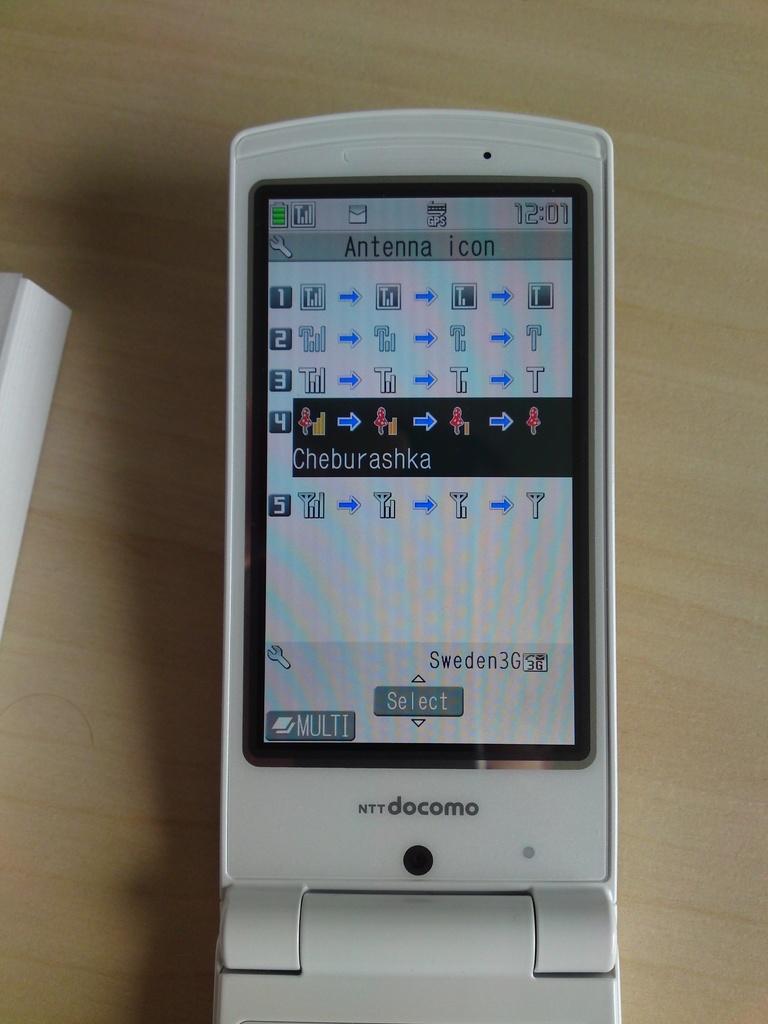What word is in gray at the bottom center of the screen?
Offer a very short reply. Select. What phone type is this?
Ensure brevity in your answer.  Docomo. 